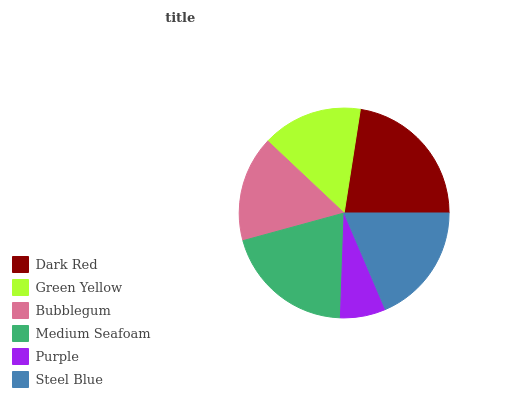Is Purple the minimum?
Answer yes or no. Yes. Is Dark Red the maximum?
Answer yes or no. Yes. Is Green Yellow the minimum?
Answer yes or no. No. Is Green Yellow the maximum?
Answer yes or no. No. Is Dark Red greater than Green Yellow?
Answer yes or no. Yes. Is Green Yellow less than Dark Red?
Answer yes or no. Yes. Is Green Yellow greater than Dark Red?
Answer yes or no. No. Is Dark Red less than Green Yellow?
Answer yes or no. No. Is Steel Blue the high median?
Answer yes or no. Yes. Is Bubblegum the low median?
Answer yes or no. Yes. Is Purple the high median?
Answer yes or no. No. Is Medium Seafoam the low median?
Answer yes or no. No. 